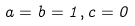<formula> <loc_0><loc_0><loc_500><loc_500>a = b = 1 , c = 0</formula> 